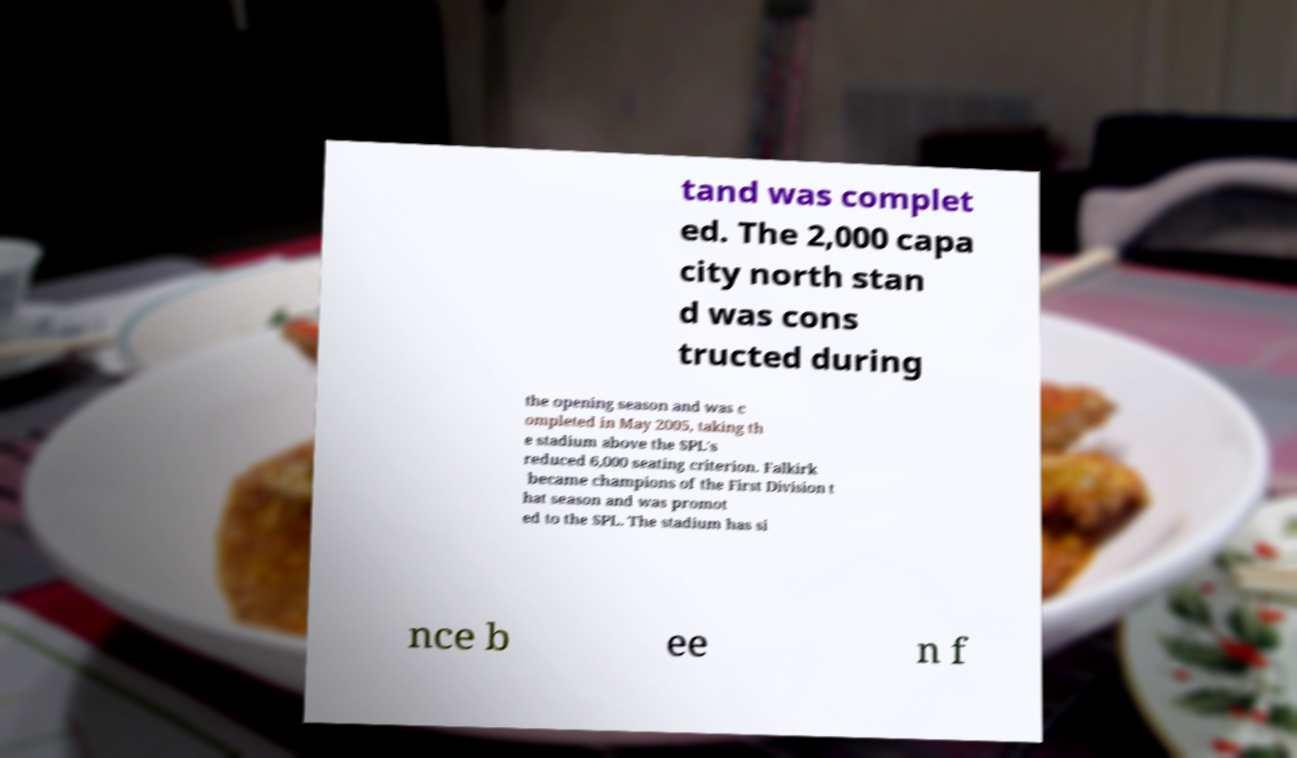I need the written content from this picture converted into text. Can you do that? tand was complet ed. The 2,000 capa city north stan d was cons tructed during the opening season and was c ompleted in May 2005, taking th e stadium above the SPL's reduced 6,000 seating criterion. Falkirk became champions of the First Division t hat season and was promot ed to the SPL. The stadium has si nce b ee n f 